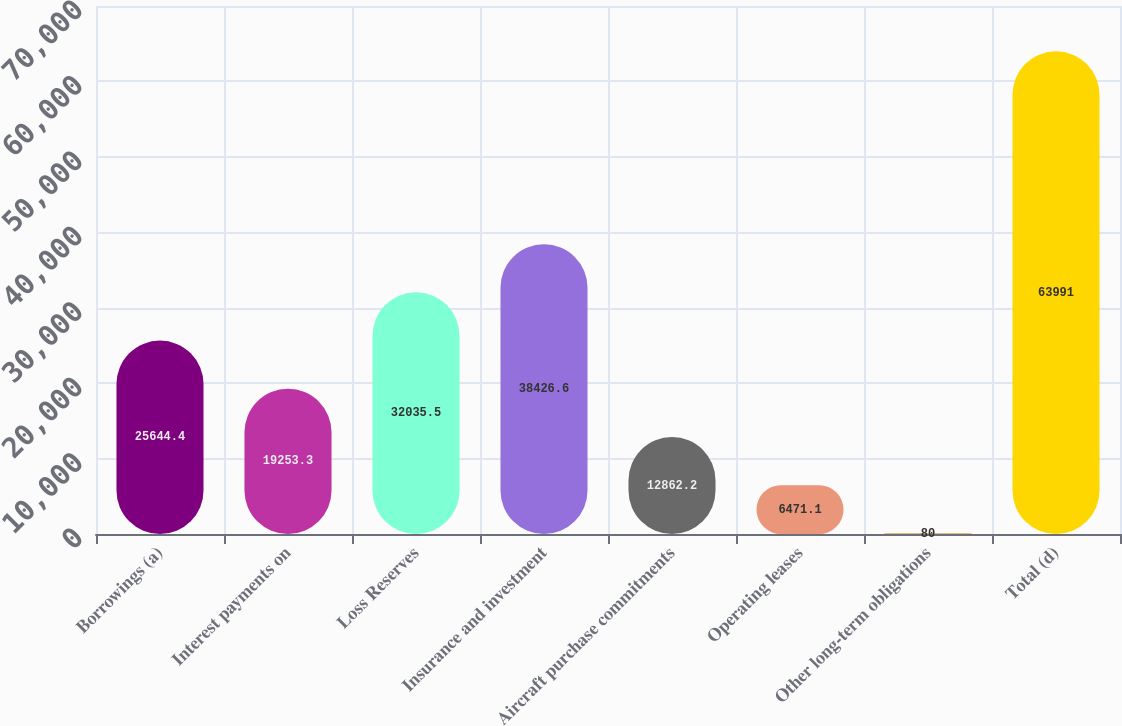Convert chart. <chart><loc_0><loc_0><loc_500><loc_500><bar_chart><fcel>Borrowings (a)<fcel>Interest payments on<fcel>Loss Reserves<fcel>Insurance and investment<fcel>Aircraft purchase commitments<fcel>Operating leases<fcel>Other long-term obligations<fcel>Total (d)<nl><fcel>25644.4<fcel>19253.3<fcel>32035.5<fcel>38426.6<fcel>12862.2<fcel>6471.1<fcel>80<fcel>63991<nl></chart> 